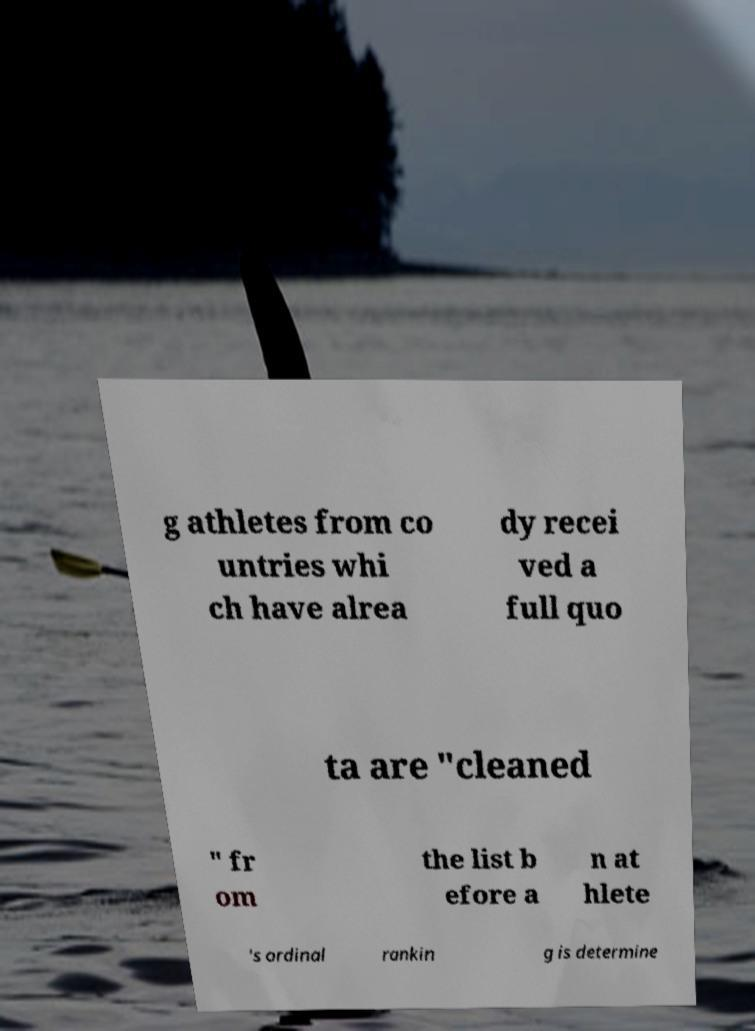There's text embedded in this image that I need extracted. Can you transcribe it verbatim? g athletes from co untries whi ch have alrea dy recei ved a full quo ta are "cleaned " fr om the list b efore a n at hlete 's ordinal rankin g is determine 